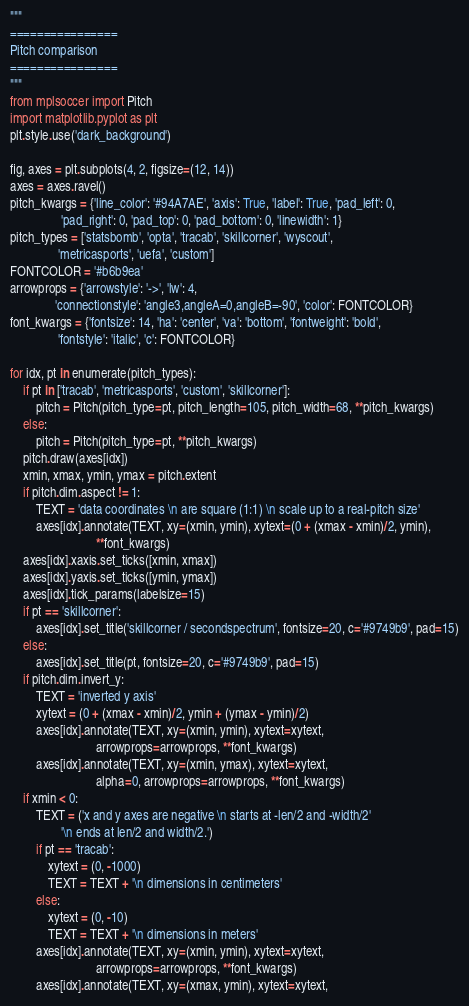<code> <loc_0><loc_0><loc_500><loc_500><_Python_>"""
================
Pitch comparison
================
"""
from mplsoccer import Pitch
import matplotlib.pyplot as plt
plt.style.use('dark_background')

fig, axes = plt.subplots(4, 2, figsize=(12, 14))
axes = axes.ravel()
pitch_kwargs = {'line_color': '#94A7AE', 'axis': True, 'label': True, 'pad_left': 0,
                'pad_right': 0, 'pad_top': 0, 'pad_bottom': 0, 'linewidth': 1}
pitch_types = ['statsbomb', 'opta', 'tracab', 'skillcorner', 'wyscout',
               'metricasports', 'uefa', 'custom']
FONTCOLOR = '#b6b9ea'
arrowprops = {'arrowstyle': '->', 'lw': 4,
              'connectionstyle': 'angle3,angleA=0,angleB=-90', 'color': FONTCOLOR}
font_kwargs = {'fontsize': 14, 'ha': 'center', 'va': 'bottom', 'fontweight': 'bold',
               'fontstyle': 'italic', 'c': FONTCOLOR}

for idx, pt in enumerate(pitch_types):
    if pt in ['tracab', 'metricasports', 'custom', 'skillcorner']:
        pitch = Pitch(pitch_type=pt, pitch_length=105, pitch_width=68, **pitch_kwargs)
    else:
        pitch = Pitch(pitch_type=pt, **pitch_kwargs)
    pitch.draw(axes[idx])
    xmin, xmax, ymin, ymax = pitch.extent
    if pitch.dim.aspect != 1:
        TEXT = 'data coordinates \n are square (1:1) \n scale up to a real-pitch size'
        axes[idx].annotate(TEXT, xy=(xmin, ymin), xytext=(0 + (xmax - xmin)/2, ymin),
                           **font_kwargs)
    axes[idx].xaxis.set_ticks([xmin, xmax])
    axes[idx].yaxis.set_ticks([ymin, ymax])
    axes[idx].tick_params(labelsize=15)
    if pt == 'skillcorner':
        axes[idx].set_title('skillcorner / secondspectrum', fontsize=20, c='#9749b9', pad=15)
    else:
        axes[idx].set_title(pt, fontsize=20, c='#9749b9', pad=15)
    if pitch.dim.invert_y:
        TEXT = 'inverted y axis'
        xytext = (0 + (xmax - xmin)/2, ymin + (ymax - ymin)/2)
        axes[idx].annotate(TEXT, xy=(xmin, ymin), xytext=xytext,
                           arrowprops=arrowprops, **font_kwargs)
        axes[idx].annotate(TEXT, xy=(xmin, ymax), xytext=xytext,
                           alpha=0, arrowprops=arrowprops, **font_kwargs)
    if xmin < 0:
        TEXT = ('x and y axes are negative \n starts at -len/2 and -width/2'
                '\n ends at len/2 and width/2.')
        if pt == 'tracab':
            xytext = (0, -1000)
            TEXT = TEXT + '\n dimensions in centimeters'
        else:
            xytext = (0, -10)
            TEXT = TEXT + '\n dimensions in meters'
        axes[idx].annotate(TEXT, xy=(xmin, ymin), xytext=xytext,
                           arrowprops=arrowprops, **font_kwargs)
        axes[idx].annotate(TEXT, xy=(xmax, ymin), xytext=xytext,</code> 